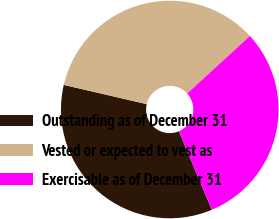Convert chart to OTSL. <chart><loc_0><loc_0><loc_500><loc_500><pie_chart><fcel>Outstanding as of December 31<fcel>Vested or expected to vest as<fcel>Exercisable as of December 31<nl><fcel>34.96%<fcel>34.56%<fcel>30.49%<nl></chart> 